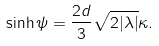Convert formula to latex. <formula><loc_0><loc_0><loc_500><loc_500>\sinh \psi = \frac { 2 d } 3 \sqrt { 2 | \lambda | } \kappa .</formula> 